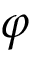Convert formula to latex. <formula><loc_0><loc_0><loc_500><loc_500>\varphi</formula> 